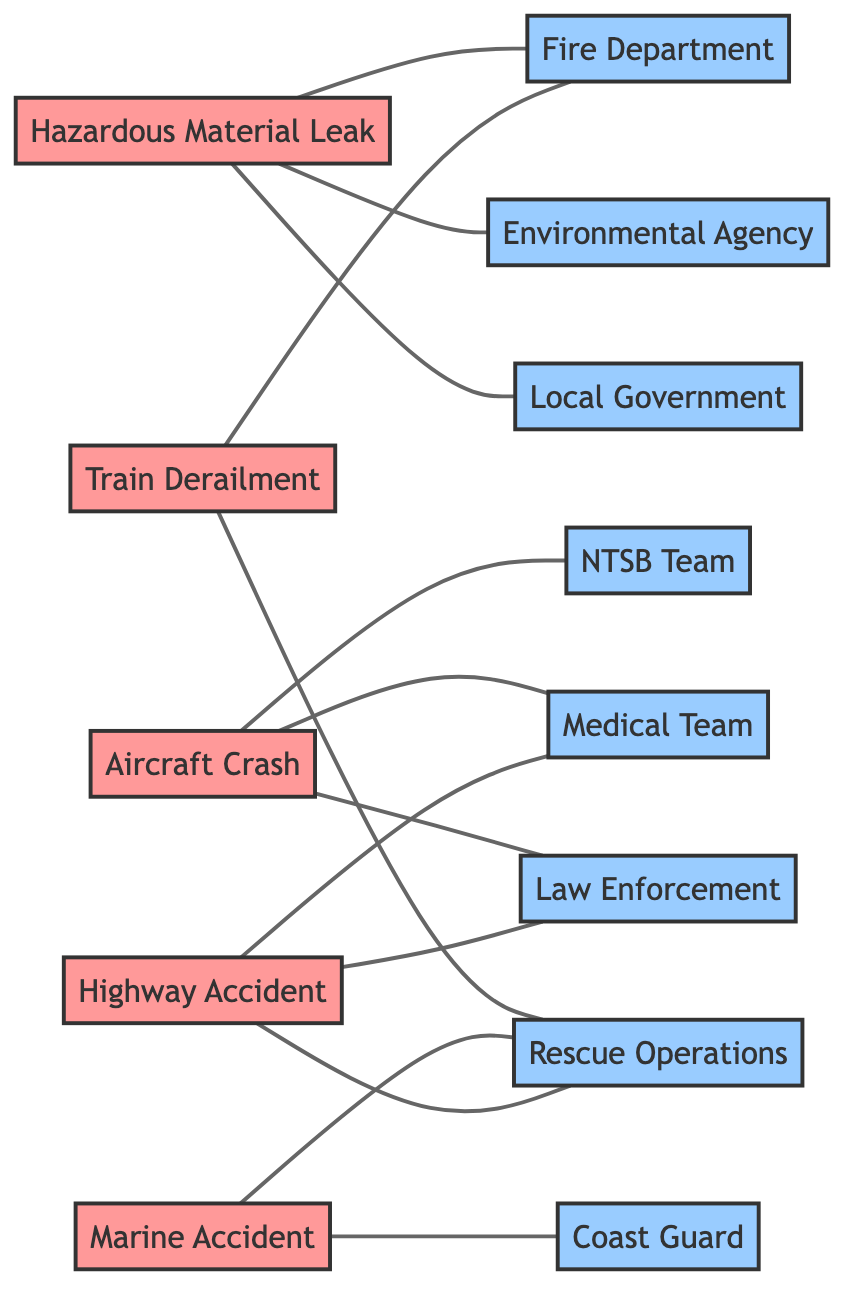What incident type is connected to the NTSB Team? The NTSB Team is connected to the Aircraft Crash incident type in the diagram. This can be identified by tracing the edge from the Aircraft Crash node to the NTSB Team node.
Answer: Aircraft Crash How many different incident types are represented in the graph? The graph contains five different incident types: Hazardous Material Leak, Aircraft Crash, Train Derailment, Marine Accident, and Highway Accident. This can be counted by identifying the nodes labeled as incidents.
Answer: 5 Which teams are related to Highway Accident? The Highway Accident incident type is connected to three teams: Law Enforcement, Medical Team, and Rescue Operations. This is determined by examining the edges that lead from the Highway Accident node.
Answer: Law Enforcement, Medical Team, Rescue Operations What is the total number of edges in the diagram? The total number of edges is the count of connections between nodes. In this diagram, there are 12 edges connecting the incident types with their respective teams. This can be calculated by counting each connection depicted in the diagram.
Answer: 12 Which incident type has connections to both the Rescue Operations and Fire Department? The Train Derailment incident type has connections to both the Rescue Operations and Fire Department. This can be confirmed by following the edges from the Train Derailment node to those two team nodes.
Answer: Train Derailment How many teams are involved in Marine Accident? The Marine Accident incident is connected to two teams: Coast Guard and Rescue Operations. This is determined by observing the edges extending from the Marine Accident node in the diagram.
Answer: 2 Which incident type corresponds with the Environmental Agency? The Hazardous Material Leak incident type corresponds with the Environmental Agency, as can be seen from the direct edge connecting these two nodes in the diagram.
Answer: Hazardous Material Leak What is the relationship between Hazardous Material Leak and Local Government? The relationship between Hazardous Material Leak and Local Government is a direct connection, indicating that Local Government is a responding team to this type of incident. This is evident from the edge linking the two nodes.
Answer: Direct connection 